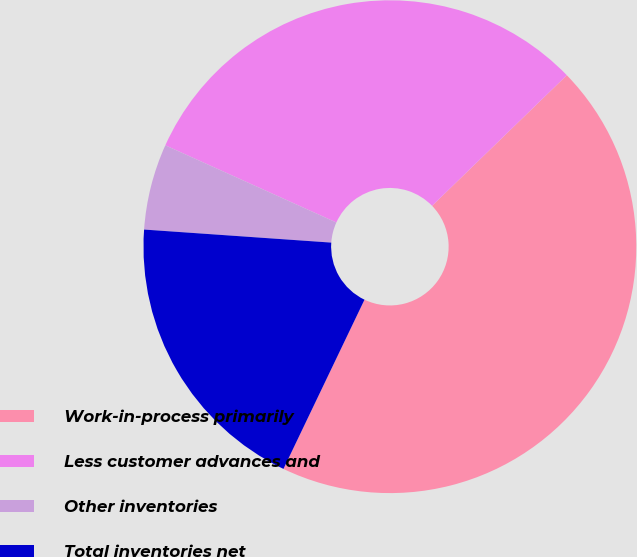Convert chart to OTSL. <chart><loc_0><loc_0><loc_500><loc_500><pie_chart><fcel>Work-in-process primarily<fcel>Less customer advances and<fcel>Other inventories<fcel>Total inventories net<nl><fcel>44.36%<fcel>31.0%<fcel>5.64%<fcel>19.0%<nl></chart> 